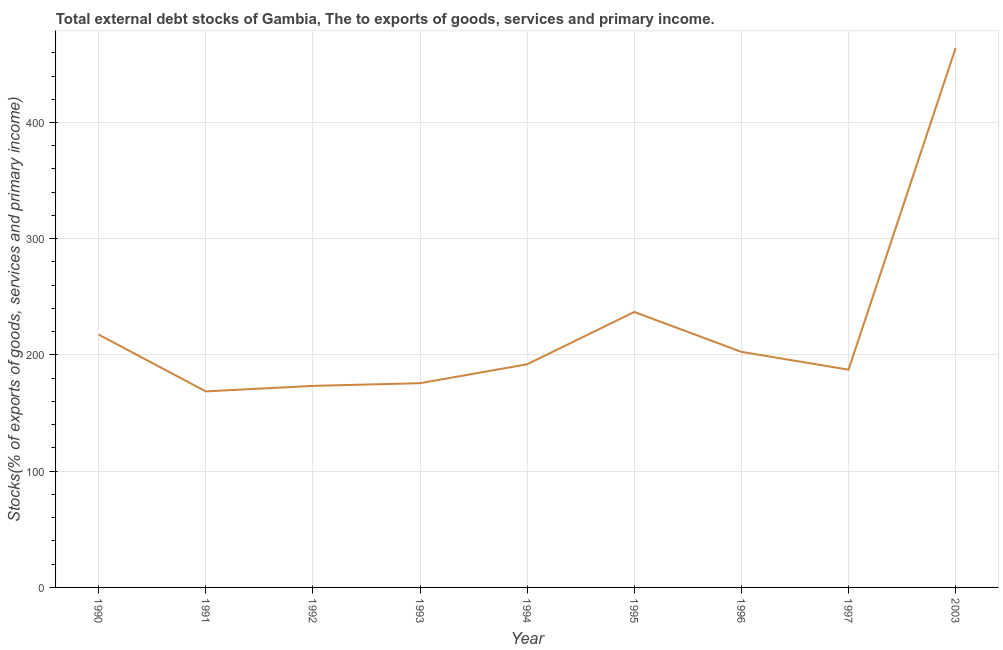What is the external debt stocks in 1990?
Provide a succinct answer. 217.51. Across all years, what is the maximum external debt stocks?
Make the answer very short. 464.1. Across all years, what is the minimum external debt stocks?
Provide a succinct answer. 168.66. What is the sum of the external debt stocks?
Keep it short and to the point. 2018.35. What is the difference between the external debt stocks in 1994 and 1996?
Provide a short and direct response. -10.65. What is the average external debt stocks per year?
Offer a terse response. 224.26. What is the median external debt stocks?
Your response must be concise. 192. What is the ratio of the external debt stocks in 1995 to that in 1996?
Make the answer very short. 1.17. Is the external debt stocks in 1991 less than that in 1994?
Provide a short and direct response. Yes. What is the difference between the highest and the second highest external debt stocks?
Make the answer very short. 227.13. What is the difference between the highest and the lowest external debt stocks?
Your answer should be very brief. 295.44. Does the external debt stocks monotonically increase over the years?
Make the answer very short. No. How many lines are there?
Your answer should be compact. 1. How many years are there in the graph?
Your answer should be compact. 9. Does the graph contain grids?
Give a very brief answer. Yes. What is the title of the graph?
Your answer should be very brief. Total external debt stocks of Gambia, The to exports of goods, services and primary income. What is the label or title of the Y-axis?
Keep it short and to the point. Stocks(% of exports of goods, services and primary income). What is the Stocks(% of exports of goods, services and primary income) of 1990?
Ensure brevity in your answer.  217.51. What is the Stocks(% of exports of goods, services and primary income) of 1991?
Give a very brief answer. 168.66. What is the Stocks(% of exports of goods, services and primary income) of 1992?
Give a very brief answer. 173.39. What is the Stocks(% of exports of goods, services and primary income) in 1993?
Offer a very short reply. 175.72. What is the Stocks(% of exports of goods, services and primary income) of 1994?
Keep it short and to the point. 192. What is the Stocks(% of exports of goods, services and primary income) of 1995?
Ensure brevity in your answer.  236.97. What is the Stocks(% of exports of goods, services and primary income) in 1996?
Keep it short and to the point. 202.66. What is the Stocks(% of exports of goods, services and primary income) of 1997?
Give a very brief answer. 187.34. What is the Stocks(% of exports of goods, services and primary income) in 2003?
Provide a succinct answer. 464.1. What is the difference between the Stocks(% of exports of goods, services and primary income) in 1990 and 1991?
Your response must be concise. 48.85. What is the difference between the Stocks(% of exports of goods, services and primary income) in 1990 and 1992?
Your answer should be very brief. 44.12. What is the difference between the Stocks(% of exports of goods, services and primary income) in 1990 and 1993?
Give a very brief answer. 41.79. What is the difference between the Stocks(% of exports of goods, services and primary income) in 1990 and 1994?
Offer a very short reply. 25.51. What is the difference between the Stocks(% of exports of goods, services and primary income) in 1990 and 1995?
Make the answer very short. -19.46. What is the difference between the Stocks(% of exports of goods, services and primary income) in 1990 and 1996?
Your answer should be very brief. 14.86. What is the difference between the Stocks(% of exports of goods, services and primary income) in 1990 and 1997?
Give a very brief answer. 30.17. What is the difference between the Stocks(% of exports of goods, services and primary income) in 1990 and 2003?
Your answer should be compact. -246.59. What is the difference between the Stocks(% of exports of goods, services and primary income) in 1991 and 1992?
Provide a succinct answer. -4.73. What is the difference between the Stocks(% of exports of goods, services and primary income) in 1991 and 1993?
Offer a very short reply. -7.06. What is the difference between the Stocks(% of exports of goods, services and primary income) in 1991 and 1994?
Your response must be concise. -23.34. What is the difference between the Stocks(% of exports of goods, services and primary income) in 1991 and 1995?
Provide a succinct answer. -68.31. What is the difference between the Stocks(% of exports of goods, services and primary income) in 1991 and 1996?
Keep it short and to the point. -34. What is the difference between the Stocks(% of exports of goods, services and primary income) in 1991 and 1997?
Give a very brief answer. -18.68. What is the difference between the Stocks(% of exports of goods, services and primary income) in 1991 and 2003?
Ensure brevity in your answer.  -295.44. What is the difference between the Stocks(% of exports of goods, services and primary income) in 1992 and 1993?
Keep it short and to the point. -2.33. What is the difference between the Stocks(% of exports of goods, services and primary income) in 1992 and 1994?
Your response must be concise. -18.61. What is the difference between the Stocks(% of exports of goods, services and primary income) in 1992 and 1995?
Provide a succinct answer. -63.58. What is the difference between the Stocks(% of exports of goods, services and primary income) in 1992 and 1996?
Your answer should be compact. -29.26. What is the difference between the Stocks(% of exports of goods, services and primary income) in 1992 and 1997?
Give a very brief answer. -13.95. What is the difference between the Stocks(% of exports of goods, services and primary income) in 1992 and 2003?
Offer a terse response. -290.71. What is the difference between the Stocks(% of exports of goods, services and primary income) in 1993 and 1994?
Your response must be concise. -16.28. What is the difference between the Stocks(% of exports of goods, services and primary income) in 1993 and 1995?
Provide a succinct answer. -61.25. What is the difference between the Stocks(% of exports of goods, services and primary income) in 1993 and 1996?
Offer a very short reply. -26.93. What is the difference between the Stocks(% of exports of goods, services and primary income) in 1993 and 1997?
Give a very brief answer. -11.62. What is the difference between the Stocks(% of exports of goods, services and primary income) in 1993 and 2003?
Provide a succinct answer. -288.38. What is the difference between the Stocks(% of exports of goods, services and primary income) in 1994 and 1995?
Provide a succinct answer. -44.97. What is the difference between the Stocks(% of exports of goods, services and primary income) in 1994 and 1996?
Your answer should be very brief. -10.65. What is the difference between the Stocks(% of exports of goods, services and primary income) in 1994 and 1997?
Ensure brevity in your answer.  4.66. What is the difference between the Stocks(% of exports of goods, services and primary income) in 1994 and 2003?
Your answer should be compact. -272.1. What is the difference between the Stocks(% of exports of goods, services and primary income) in 1995 and 1996?
Your answer should be very brief. 34.32. What is the difference between the Stocks(% of exports of goods, services and primary income) in 1995 and 1997?
Ensure brevity in your answer.  49.63. What is the difference between the Stocks(% of exports of goods, services and primary income) in 1995 and 2003?
Give a very brief answer. -227.13. What is the difference between the Stocks(% of exports of goods, services and primary income) in 1996 and 1997?
Your answer should be compact. 15.31. What is the difference between the Stocks(% of exports of goods, services and primary income) in 1996 and 2003?
Give a very brief answer. -261.44. What is the difference between the Stocks(% of exports of goods, services and primary income) in 1997 and 2003?
Keep it short and to the point. -276.76. What is the ratio of the Stocks(% of exports of goods, services and primary income) in 1990 to that in 1991?
Ensure brevity in your answer.  1.29. What is the ratio of the Stocks(% of exports of goods, services and primary income) in 1990 to that in 1992?
Ensure brevity in your answer.  1.25. What is the ratio of the Stocks(% of exports of goods, services and primary income) in 1990 to that in 1993?
Provide a short and direct response. 1.24. What is the ratio of the Stocks(% of exports of goods, services and primary income) in 1990 to that in 1994?
Offer a very short reply. 1.13. What is the ratio of the Stocks(% of exports of goods, services and primary income) in 1990 to that in 1995?
Provide a succinct answer. 0.92. What is the ratio of the Stocks(% of exports of goods, services and primary income) in 1990 to that in 1996?
Offer a very short reply. 1.07. What is the ratio of the Stocks(% of exports of goods, services and primary income) in 1990 to that in 1997?
Your answer should be compact. 1.16. What is the ratio of the Stocks(% of exports of goods, services and primary income) in 1990 to that in 2003?
Ensure brevity in your answer.  0.47. What is the ratio of the Stocks(% of exports of goods, services and primary income) in 1991 to that in 1994?
Provide a succinct answer. 0.88. What is the ratio of the Stocks(% of exports of goods, services and primary income) in 1991 to that in 1995?
Give a very brief answer. 0.71. What is the ratio of the Stocks(% of exports of goods, services and primary income) in 1991 to that in 1996?
Offer a terse response. 0.83. What is the ratio of the Stocks(% of exports of goods, services and primary income) in 1991 to that in 1997?
Your answer should be compact. 0.9. What is the ratio of the Stocks(% of exports of goods, services and primary income) in 1991 to that in 2003?
Offer a very short reply. 0.36. What is the ratio of the Stocks(% of exports of goods, services and primary income) in 1992 to that in 1994?
Provide a succinct answer. 0.9. What is the ratio of the Stocks(% of exports of goods, services and primary income) in 1992 to that in 1995?
Offer a very short reply. 0.73. What is the ratio of the Stocks(% of exports of goods, services and primary income) in 1992 to that in 1996?
Offer a very short reply. 0.86. What is the ratio of the Stocks(% of exports of goods, services and primary income) in 1992 to that in 1997?
Provide a succinct answer. 0.93. What is the ratio of the Stocks(% of exports of goods, services and primary income) in 1992 to that in 2003?
Offer a very short reply. 0.37. What is the ratio of the Stocks(% of exports of goods, services and primary income) in 1993 to that in 1994?
Offer a very short reply. 0.92. What is the ratio of the Stocks(% of exports of goods, services and primary income) in 1993 to that in 1995?
Your answer should be very brief. 0.74. What is the ratio of the Stocks(% of exports of goods, services and primary income) in 1993 to that in 1996?
Give a very brief answer. 0.87. What is the ratio of the Stocks(% of exports of goods, services and primary income) in 1993 to that in 1997?
Provide a succinct answer. 0.94. What is the ratio of the Stocks(% of exports of goods, services and primary income) in 1993 to that in 2003?
Offer a very short reply. 0.38. What is the ratio of the Stocks(% of exports of goods, services and primary income) in 1994 to that in 1995?
Offer a very short reply. 0.81. What is the ratio of the Stocks(% of exports of goods, services and primary income) in 1994 to that in 1996?
Keep it short and to the point. 0.95. What is the ratio of the Stocks(% of exports of goods, services and primary income) in 1994 to that in 1997?
Keep it short and to the point. 1.02. What is the ratio of the Stocks(% of exports of goods, services and primary income) in 1994 to that in 2003?
Your answer should be very brief. 0.41. What is the ratio of the Stocks(% of exports of goods, services and primary income) in 1995 to that in 1996?
Offer a very short reply. 1.17. What is the ratio of the Stocks(% of exports of goods, services and primary income) in 1995 to that in 1997?
Your response must be concise. 1.26. What is the ratio of the Stocks(% of exports of goods, services and primary income) in 1995 to that in 2003?
Provide a succinct answer. 0.51. What is the ratio of the Stocks(% of exports of goods, services and primary income) in 1996 to that in 1997?
Keep it short and to the point. 1.08. What is the ratio of the Stocks(% of exports of goods, services and primary income) in 1996 to that in 2003?
Offer a very short reply. 0.44. What is the ratio of the Stocks(% of exports of goods, services and primary income) in 1997 to that in 2003?
Your answer should be very brief. 0.4. 